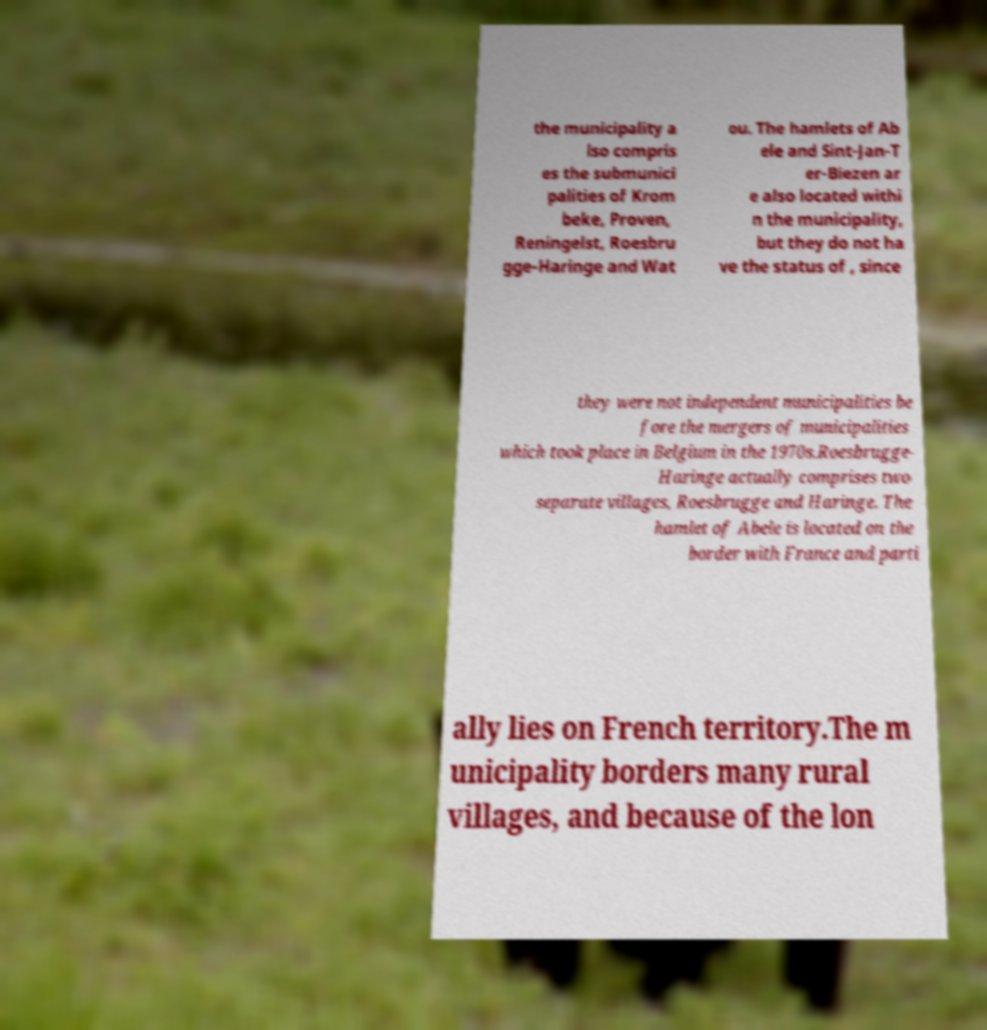There's text embedded in this image that I need extracted. Can you transcribe it verbatim? the municipality a lso compris es the submunici palities of Krom beke, Proven, Reningelst, Roesbru gge-Haringe and Wat ou. The hamlets of Ab ele and Sint-Jan-T er-Biezen ar e also located withi n the municipality, but they do not ha ve the status of , since they were not independent municipalities be fore the mergers of municipalities which took place in Belgium in the 1970s.Roesbrugge- Haringe actually comprises two separate villages, Roesbrugge and Haringe. The hamlet of Abele is located on the border with France and parti ally lies on French territory.The m unicipality borders many rural villages, and because of the lon 